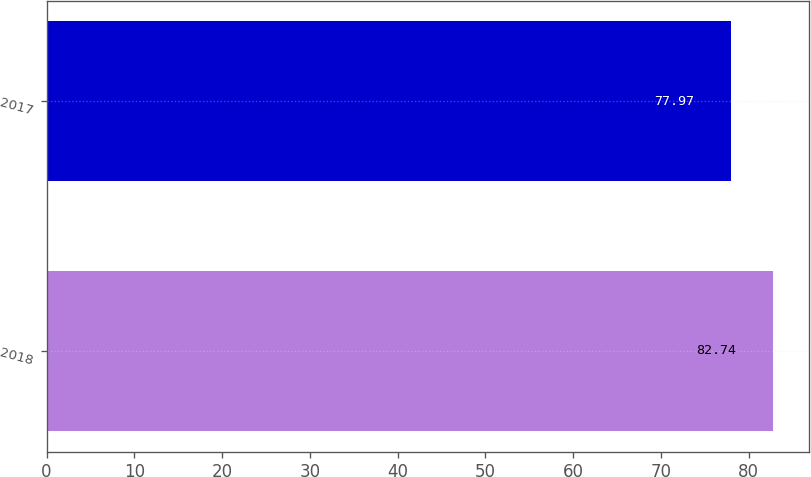Convert chart to OTSL. <chart><loc_0><loc_0><loc_500><loc_500><bar_chart><fcel>2018<fcel>2017<nl><fcel>82.74<fcel>77.97<nl></chart> 